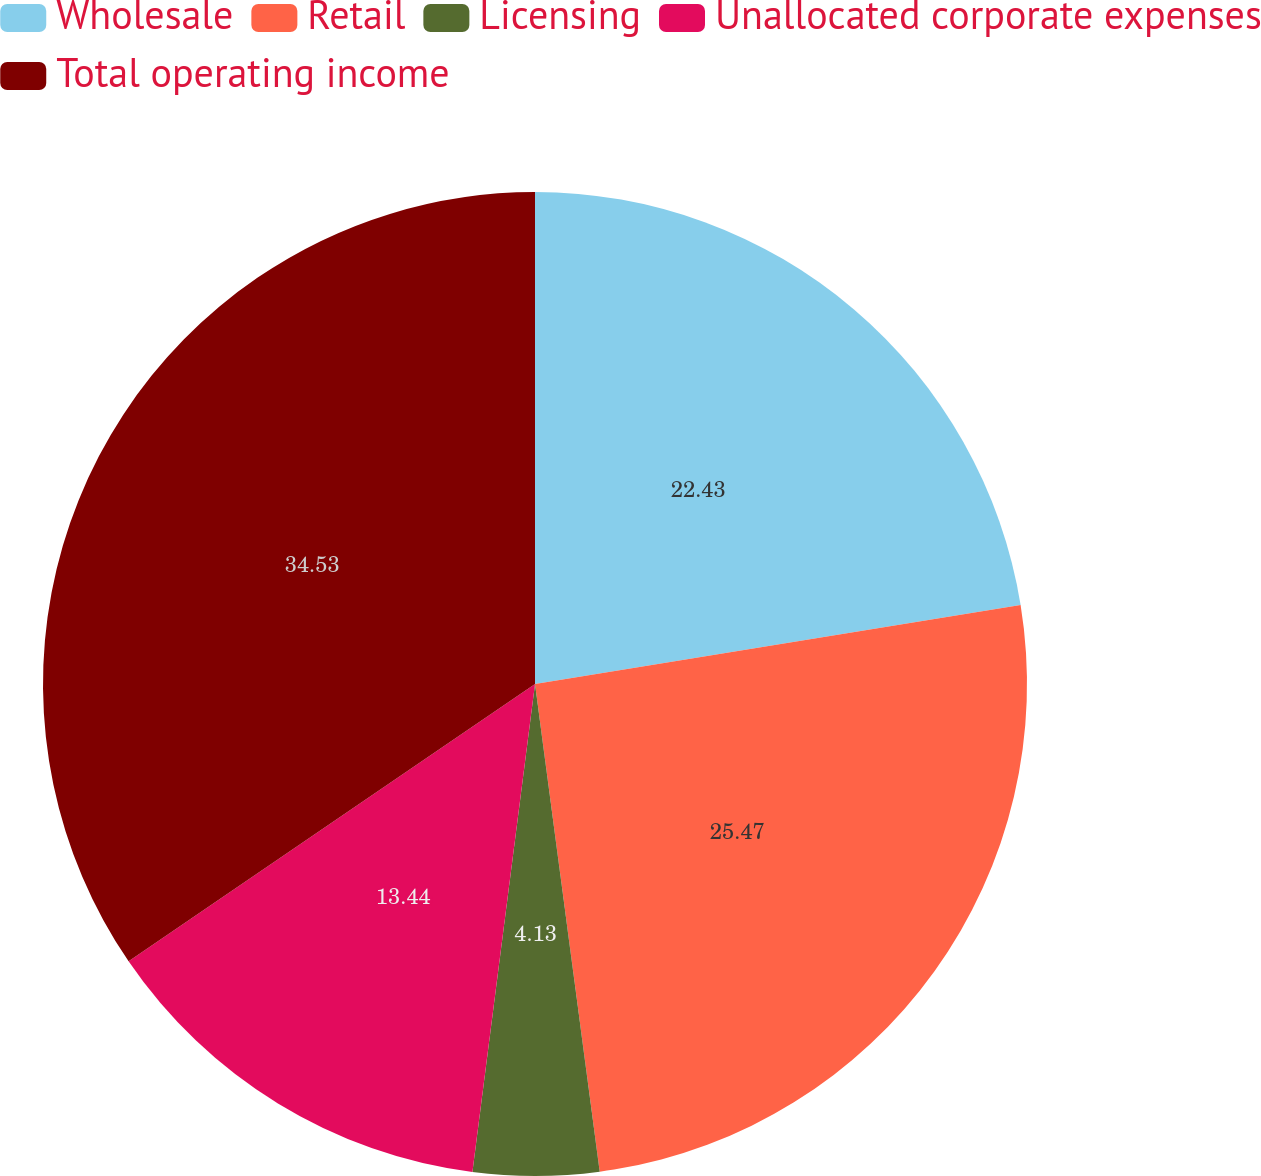Convert chart. <chart><loc_0><loc_0><loc_500><loc_500><pie_chart><fcel>Wholesale<fcel>Retail<fcel>Licensing<fcel>Unallocated corporate expenses<fcel>Total operating income<nl><fcel>22.43%<fcel>25.47%<fcel>4.13%<fcel>13.44%<fcel>34.53%<nl></chart> 